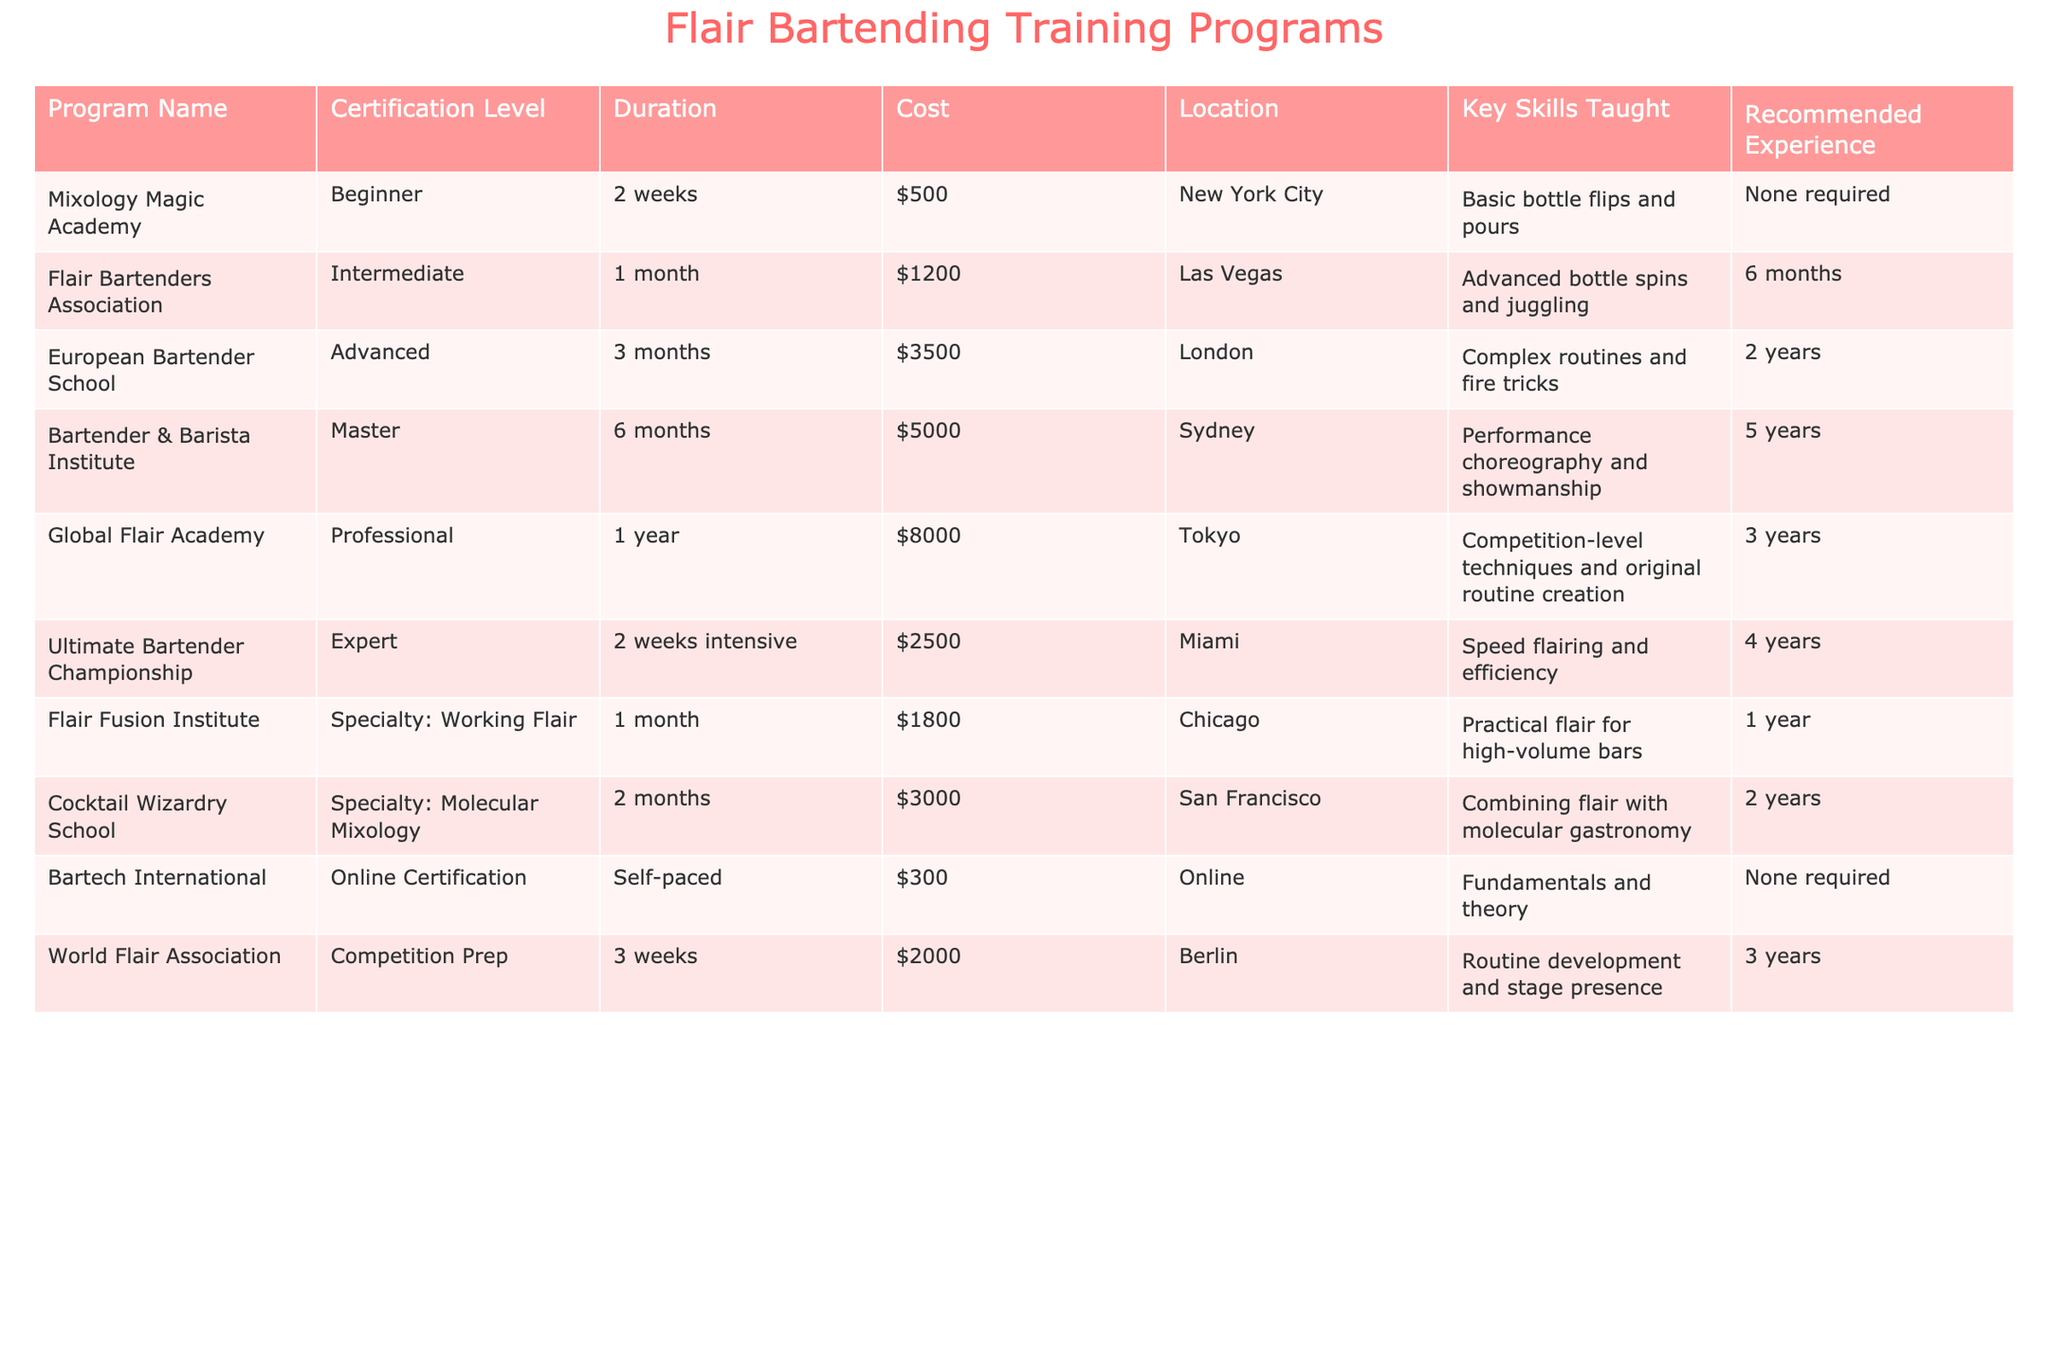What is the cost of the Mixology Magic Academy program? The Mixology Magic Academy program is listed in the table, and its cost is clearly stated as $500.
Answer: $500 How long does it take to complete the Flair Bartenders Association program? From the table, the Flair Bartenders Association program takes 1 month to complete.
Answer: 1 month Which program has the highest certification level? According to the table, the program with the highest certification level is the Bartender & Barista Institute, which offers a Master level certification.
Answer: Bartender & Barista Institute What are the recommended experience requirements for the European Bartender School? The table indicates that the European Bartender School requires 2 years of recommended experience.
Answer: 2 years Is the Ultimate Bartender Championship program available in an online format? The table shows that the Ultimate Bartender Championship program is an in-person program and does not mention an online format, implying that it is not available online.
Answer: No Calculate the average duration of all programs listed in the table. To calculate the average duration, first convert the durations into weeks: Mixology Magic Academy (2), Flair Bartenders Association (4), European Bartender School (12), Bartender & Barista Institute (24), Global Flair Academy (52), Ultimate Bartender Championship (2), Flair Fusion Institute (4), Cocktail Wizardry School (8), Bartech International (0), World Flair Association (3). The total duration in weeks is 2 + 4 + 12 + 24 + 52 + 2 + 4 + 8 + 0 + 3 = 111 weeks. There are 10 programs, so the average duration is 111 / 10 = 11.1 weeks.
Answer: 11.1 weeks Which program has the lowest cost, and what is that cost? The table shows the Bartech International program has the lowest cost of $300.
Answer: Bartech International, $300 What key skill is taught in the Flair Fusion Institute program? From the table, the key skill taught in the Flair Fusion Institute program is practical flair for high-volume bars.
Answer: Practical flair for high-volume bars Identify one program that requires no previous experience. The table notes that both the Mixology Magic Academy and Bartech International programs require no previous experience.
Answer: Mixology Magic Academy (or Bartech International) 